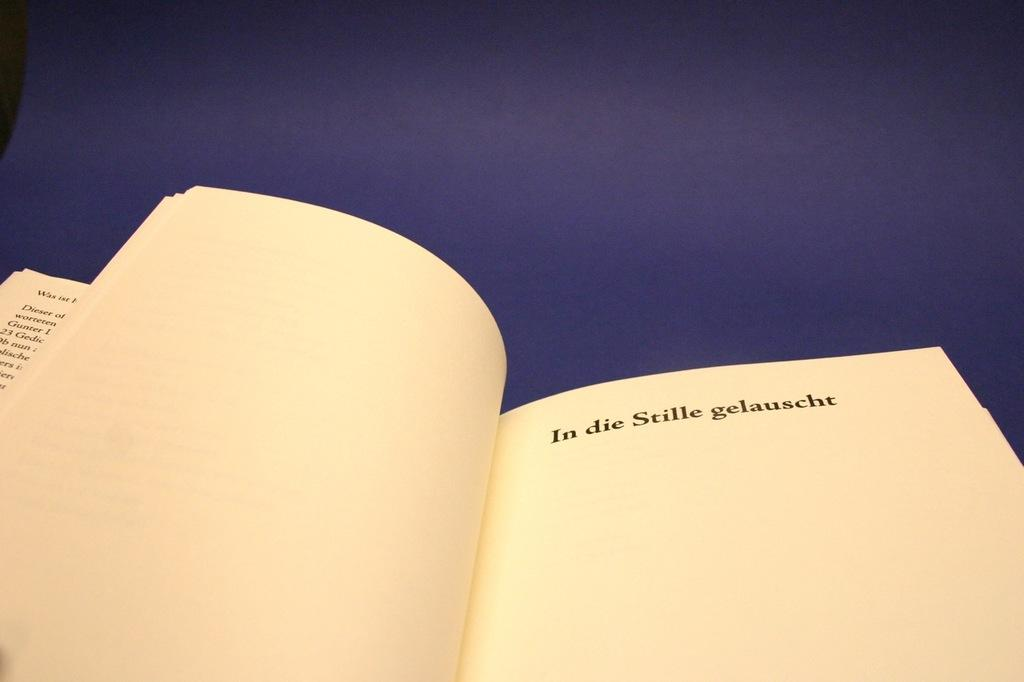<image>
Relay a brief, clear account of the picture shown. A book is open to a page that simply says In die Stille gelauscht. 